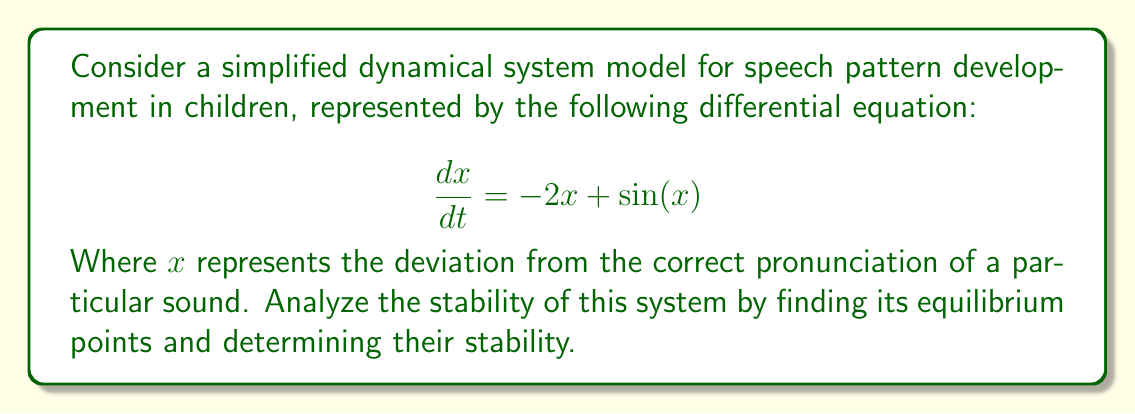Help me with this question. 1) First, we need to find the equilibrium points. These occur when $\frac{dx}{dt} = 0$:

   $$-2x + \sin(x) = 0$$

2) This equation cannot be solved analytically, but we can see that $x = 0$ is a solution. Let's call this equilibrium point $x_1 = 0$.

3) There is another equilibrium point between 1 and 2 (where $\sin(x)$ intersects $2x$). We can approximate this numerically as $x_2 \approx 1.4$.

4) To determine stability, we need to find the derivative of the right-hand side with respect to $x$:

   $$\frac{d}{dx}(-2x + \sin(x)) = -2 + \cos(x)$$

5) Now, we evaluate this at each equilibrium point:

   At $x_1 = 0$: $-2 + \cos(0) = -1$
   At $x_2 \approx 1.4$: $-2 + \cos(1.4) \approx -2.17$

6) For a one-dimensional system, if this derivative is negative at an equilibrium point, that point is stable. If it's positive, the point is unstable.

7) Since both values are negative, both equilibrium points are stable.

8) Interpreting this in the context of speech therapy:
   - $x_1 = 0$ represents perfect pronunciation (no deviation).
   - $x_2 \approx 1.4$ represents a "local accent" or habitual mispronunciation.
   - Both are stable, meaning a child might naturally tend towards either perfect pronunciation or a consistent mispronunciation without intervention.
Answer: The system has two stable equilibrium points: $x_1 = 0$ and $x_2 \approx 1.4$. 